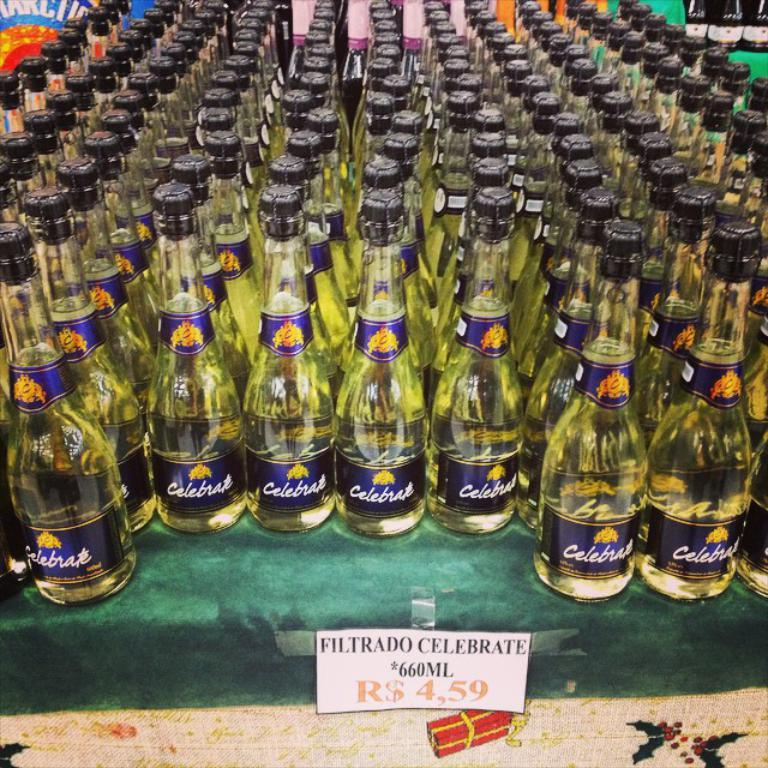<image>
Write a terse but informative summary of the picture. an entire table of filtrado celebrate is for sale 